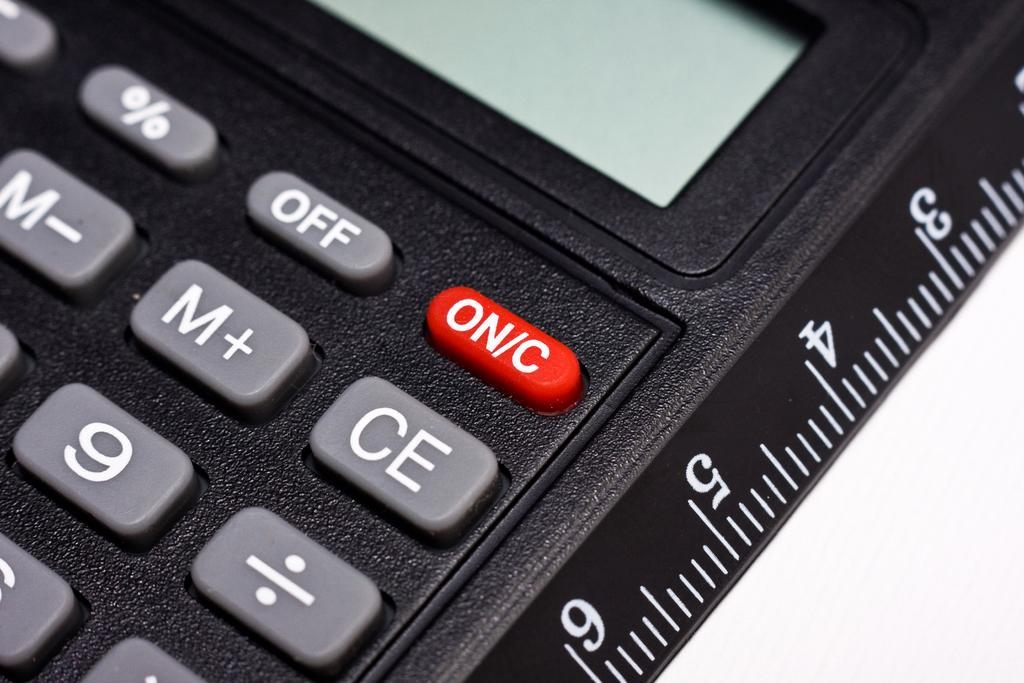Provide a one-sentence caption for the provided image. A black calculator features buttons labelled "off" and "on/c". 